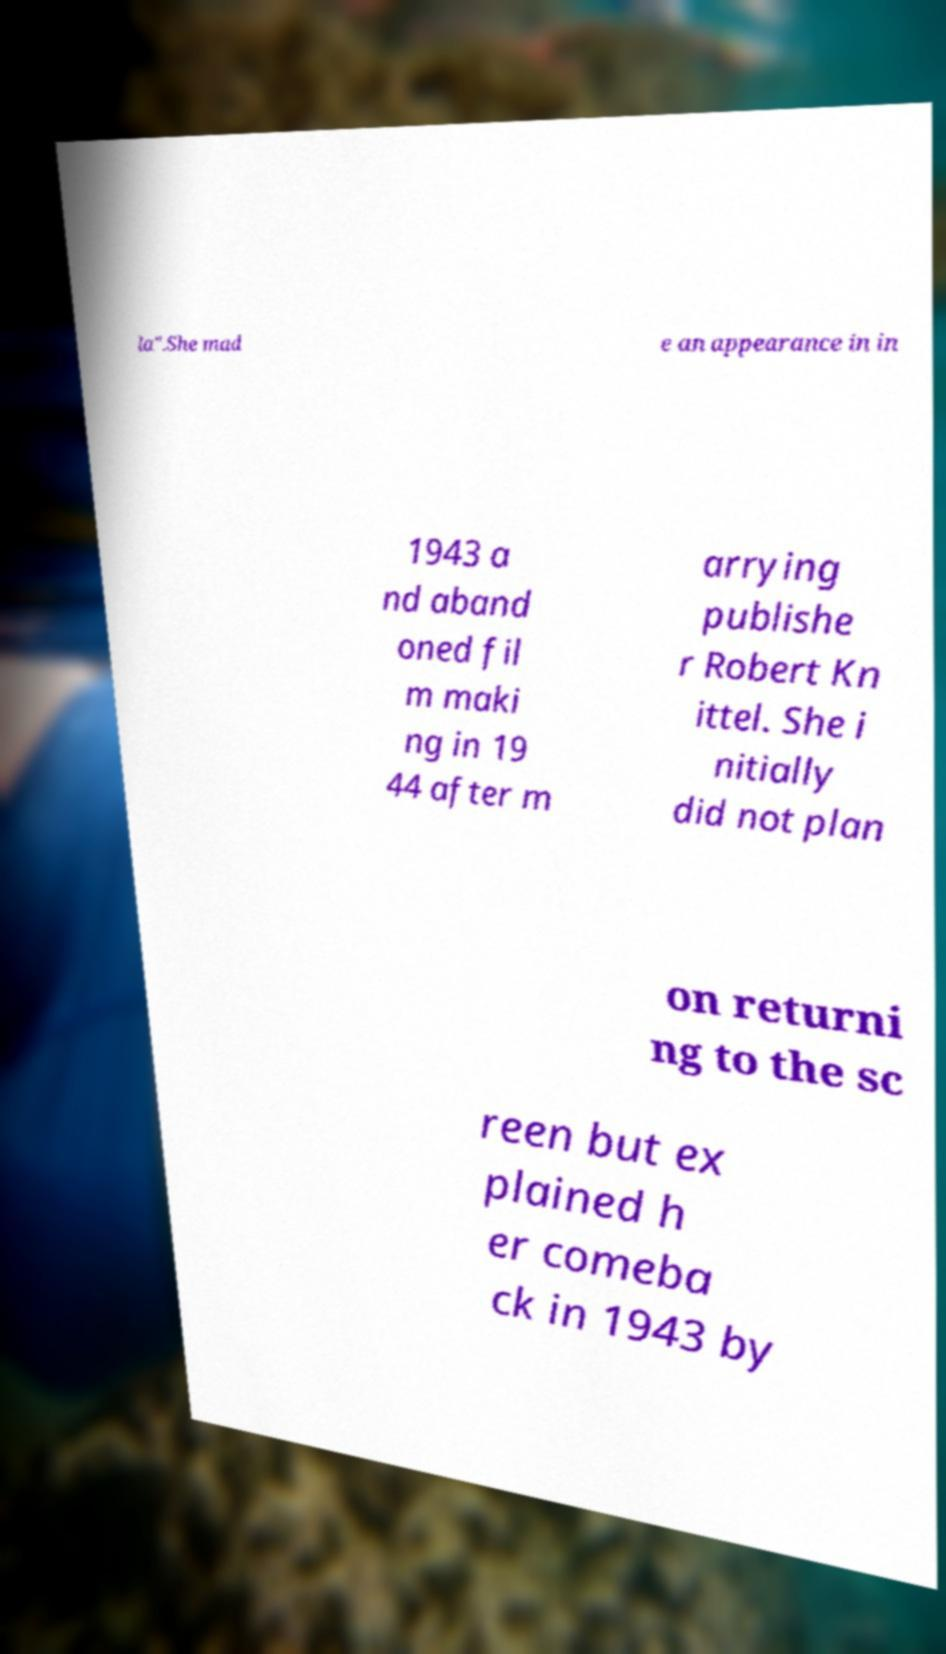For documentation purposes, I need the text within this image transcribed. Could you provide that? la".She mad e an appearance in in 1943 a nd aband oned fil m maki ng in 19 44 after m arrying publishe r Robert Kn ittel. She i nitially did not plan on returni ng to the sc reen but ex plained h er comeba ck in 1943 by 